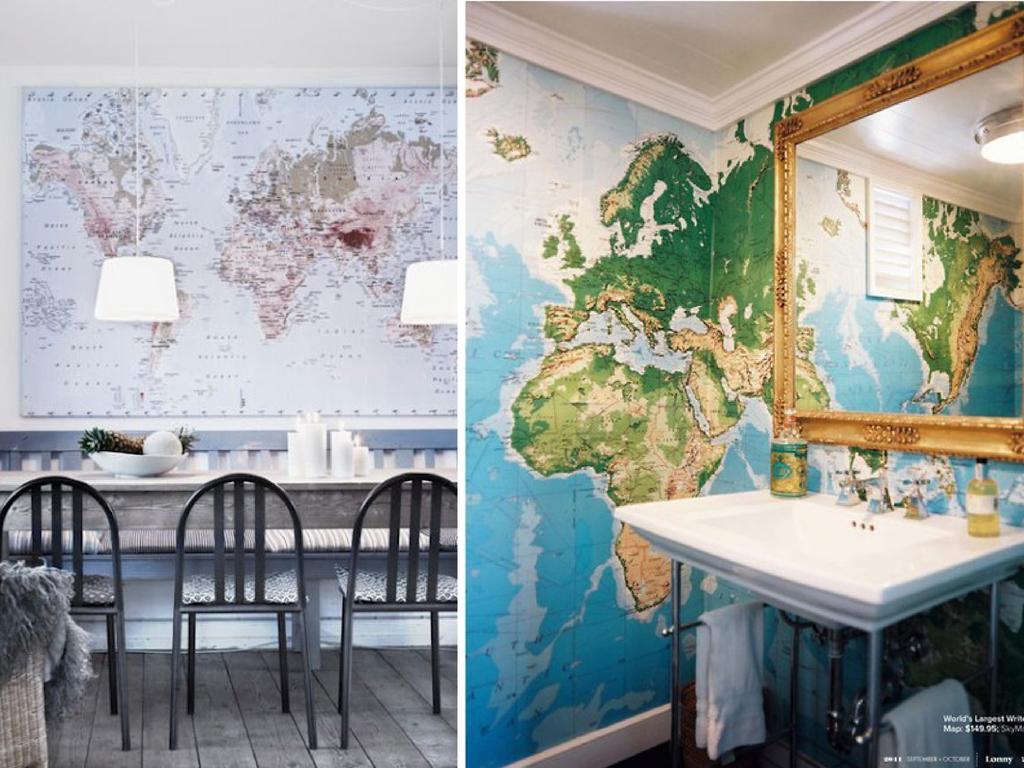Describe this image in one or two sentences. This is a collage picture. I can see few objects on the table and on the washbasin, there are napkins, chairs, lights, there are maps as a wall poster and as a board on the wall, there is a mirror and there are watermarks on the image. 